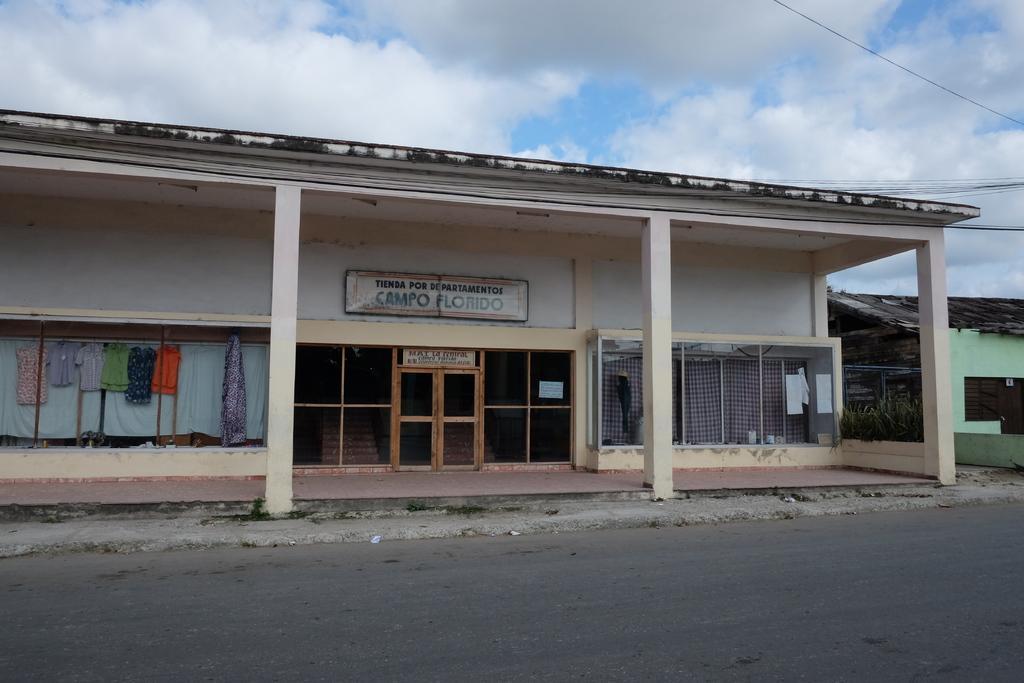Describe this image in one or two sentences. In this image, we can see a few houses. Among them, one of the houses has a door and some glass windows. We can see some clothes. There are some wires. We can see the ground and the sky with clouds. We can see some boards with text written. 